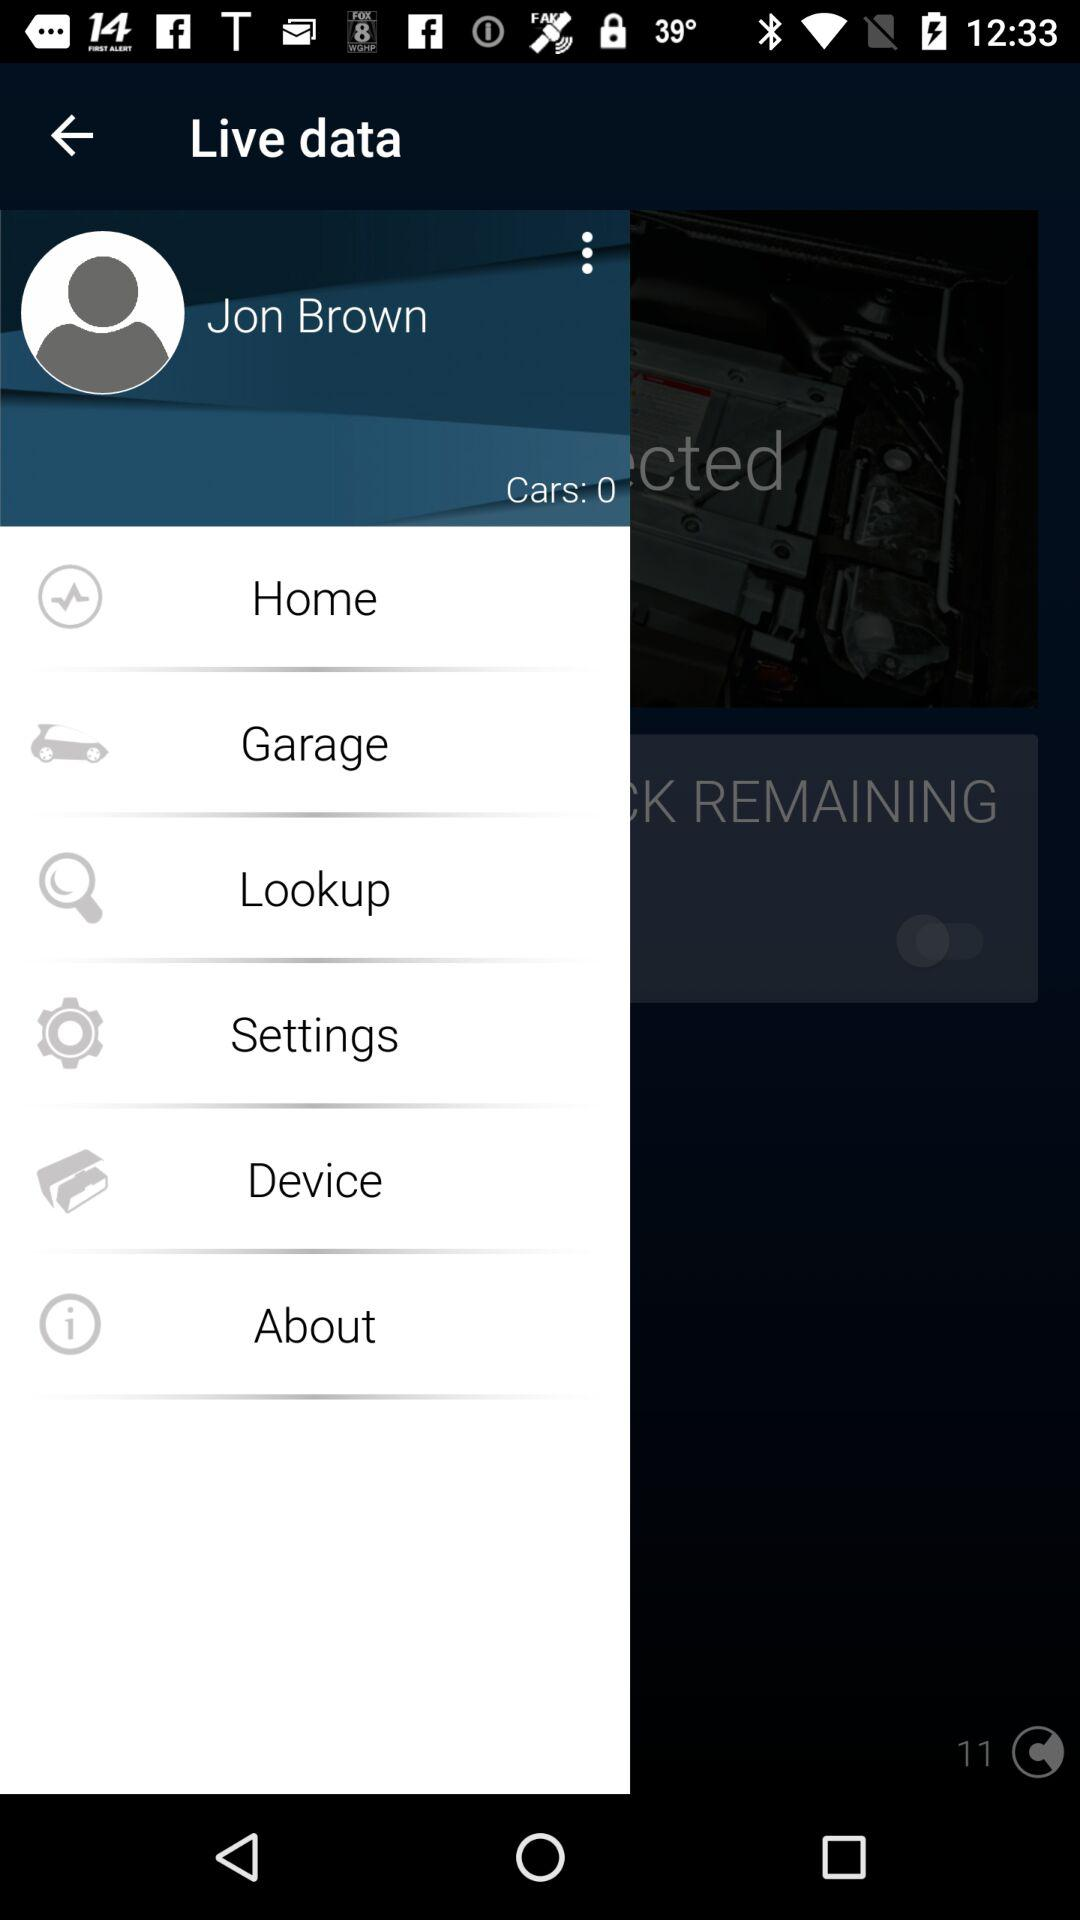What is the user name? The user name is Jon Brown. 